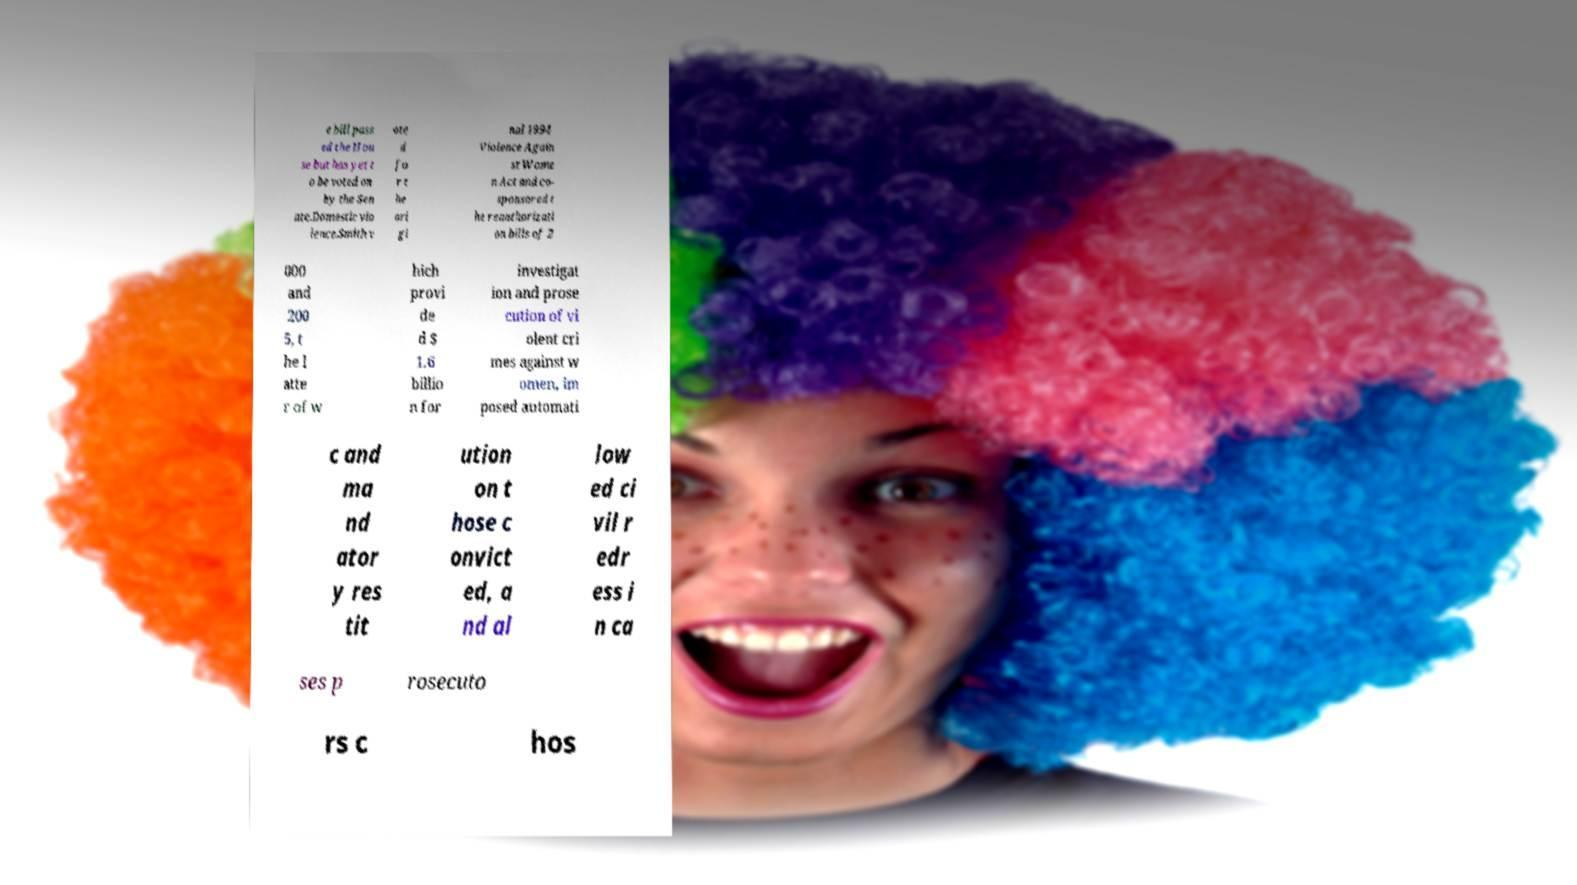What messages or text are displayed in this image? I need them in a readable, typed format. e bill pass ed the Hou se but has yet t o be voted on by the Sen ate.Domestic vio lence.Smith v ote d fo r t he ori gi nal 1994 Violence Again st Wome n Act and co- sponsored t he reauthorizati on bills of 2 000 and 200 5, t he l atte r of w hich provi de d $ 1.6 billio n for investigat ion and prose cution of vi olent cri mes against w omen, im posed automati c and ma nd ator y res tit ution on t hose c onvict ed, a nd al low ed ci vil r edr ess i n ca ses p rosecuto rs c hos 